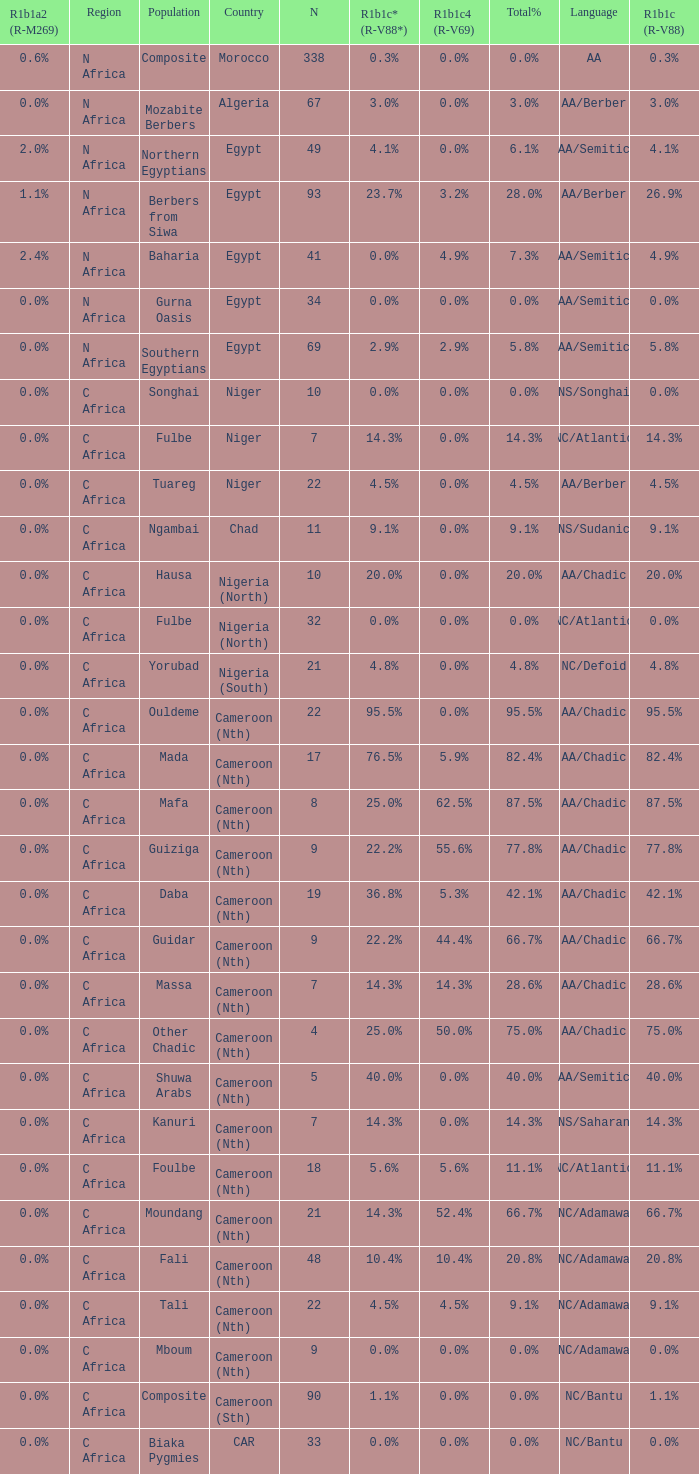What percentage is listed in column r1b1a2 (r-m269) for the 77.8% r1b1c (r-v88)? 0.0%. 